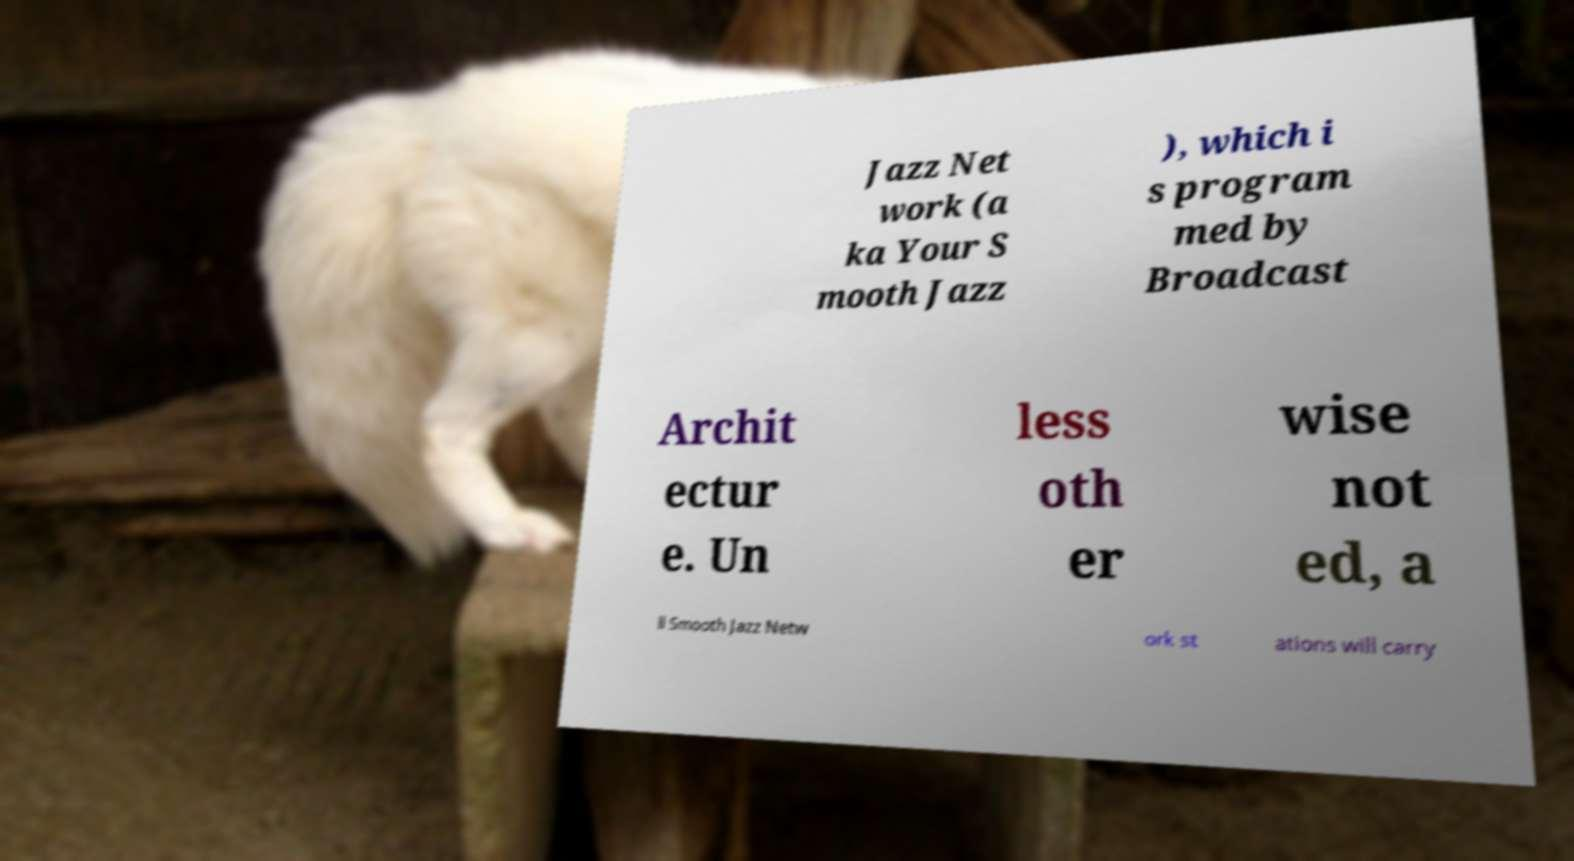I need the written content from this picture converted into text. Can you do that? Jazz Net work (a ka Your S mooth Jazz ), which i s program med by Broadcast Archit ectur e. Un less oth er wise not ed, a ll Smooth Jazz Netw ork st ations will carry 